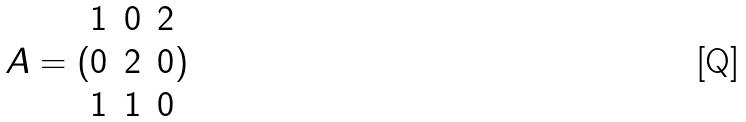<formula> <loc_0><loc_0><loc_500><loc_500>A = ( \begin{matrix} 1 & 0 & 2 \\ 0 & 2 & 0 \\ 1 & 1 & 0 \end{matrix} )</formula> 